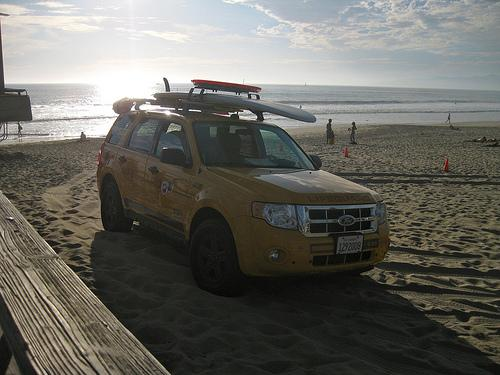Narrate the key elements of the image in simple terms. Yellow SUV, surfboards, people, sand, and ocean. Specify the key colors and entities in the image. Yellow: lifeguard Ford SUV; gray: surfboard; blue: sky; white: clouds; orange: safety cone; sand: beige. Illustrate the main vehicle in the image and its position. A yellow Ford SUV with a surfboard on the roof sits on the sandy beach near the water's edge, with the sun reflecting off the water and people wandering around. Explain the scene of the image in a few words. A lifeguard SUV on the beach with people and surfboards. Write a brief caption of the image, relating to its main subject. A Lifeguard SUV Ensures Safety at a Beautiful Beach Provide a detailed description of the central object in the image. A yellow lifeguard Ford SUV is parked on the beach with a gray surfboard on top, and the word "lifeguard" written in red on the side of the vehicle. Discuss the people and their activities in the image scene. People are walking and playing on the beach, while one person is running at a distance. The presence of a lifeguard SUV ensures safety for all beachgoers. Mention the most notable feature of the image and what it signifies. A yellow Ford lifeguard SUV, symbolizing beach safety and rescue operations. Express the atmosphere at the beach in the image. A relaxing beach day with the presence of a lifeguard vehicle, people enjoying the sand, and sun reflecting on the water. Describe the overall setting of the image. A sandy beach scene with a yellow lifeguard vehicle, people, and surfboards, set against a backdrop of the ocean and a blue sky with white clouds. Observe a bonfire burning near the water's edge. There is no mention of a bonfire or any fire in the image, which makes this instruction misleading. Is there a large green truck parked on the beach? The available objects describe a yellow emergency vehicle, not a green truck. This instruction creates confusion by changing the color of the vehicle. Find a group of people playing volleyball on the sand. There is a mention of people on the beach, but no mention of a volleyball game. This instruction creates an expectation of a specific activity not evidently showcased in the image. Can you see a red surfboard lying directly on the sand? The surfboard mentioned in the image is described as being on top of the vehicle, not lying on the sand. Additionally, the color is not specified, causing further confusion. There is an enormous mountain in the background. No mountain or any similar landscape is mentioned in the image's objects. This instruction introduces an entirely new element that does not exist in the image. Is there a black sailboat sailing on the ocean? No sailboat is mentioned in the available objects of the image. Introducing an unrelated object can mislead the viewer. Can you spot a group of seagulls flying in the sky? There are no birds or seagulls mentioned in the image's objects. Introducing new fauna can confuse the viewer. Is there an ice cream vendor selling treats to the beachgoers? There is no mention of an ice cream vendor or any such entity in the list of objects. Introducing an unexpected character who is not in the image can mislead the viewer. There's a flock of palm trees overlooking the beach. Palm trees are not mentioned in the image at all. Introducing a new and unrelated element can create confusion. Find a child playing with a sandcastle. No child or sandcastle is mentioned in the available objects. Introducing a new character and activity creates confusion. 